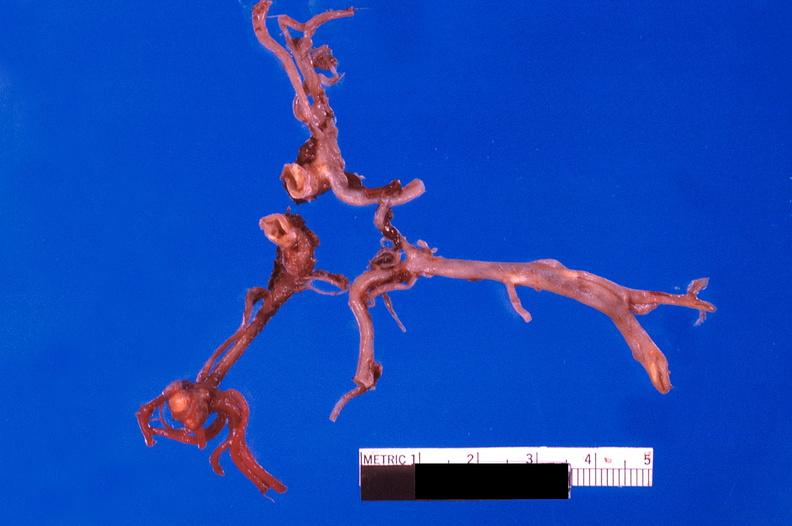does this image show ruptured saccular aneurysm right middle cerebral artery?
Answer the question using a single word or phrase. Yes 